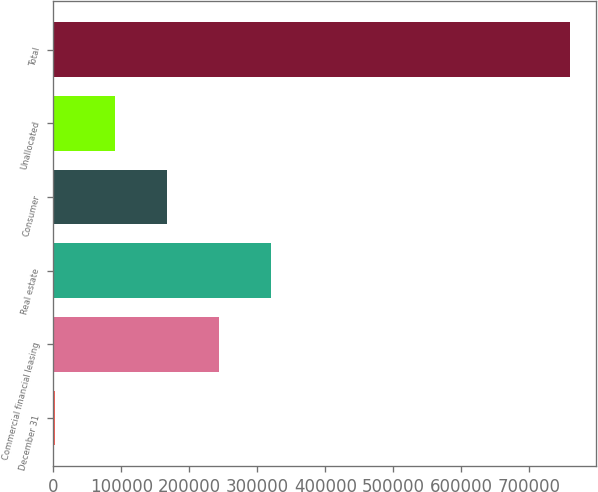<chart> <loc_0><loc_0><loc_500><loc_500><bar_chart><fcel>December 31<fcel>Commercial financial leasing<fcel>Real estate<fcel>Consumer<fcel>Unallocated<fcel>Total<nl><fcel>2007<fcel>243727<fcel>319470<fcel>167984<fcel>91495<fcel>759439<nl></chart> 